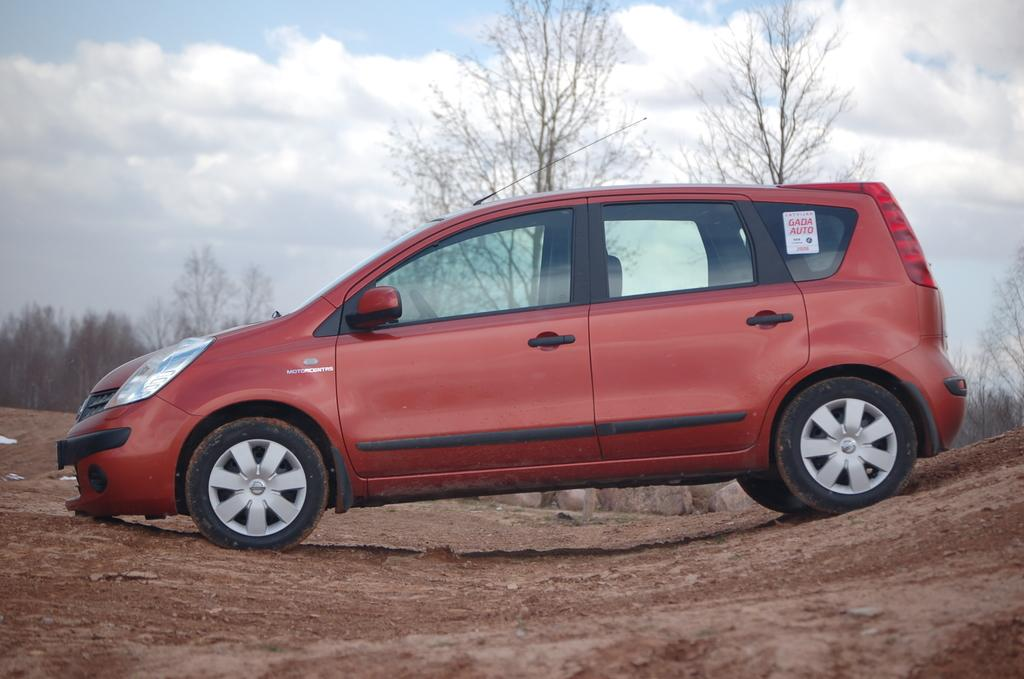What color is the vehicle in the image? The vehicle in the image is red. Where is the vehicle located? The vehicle is on the ground. What type of natural scenery can be seen in the image? There are trees visible in the image. What is visible in the background of the image? There is sky with clouds in the background of the image. What type of operation is being performed on the vessel in the image? There is no vessel present in the image, and no operation is being performed. 